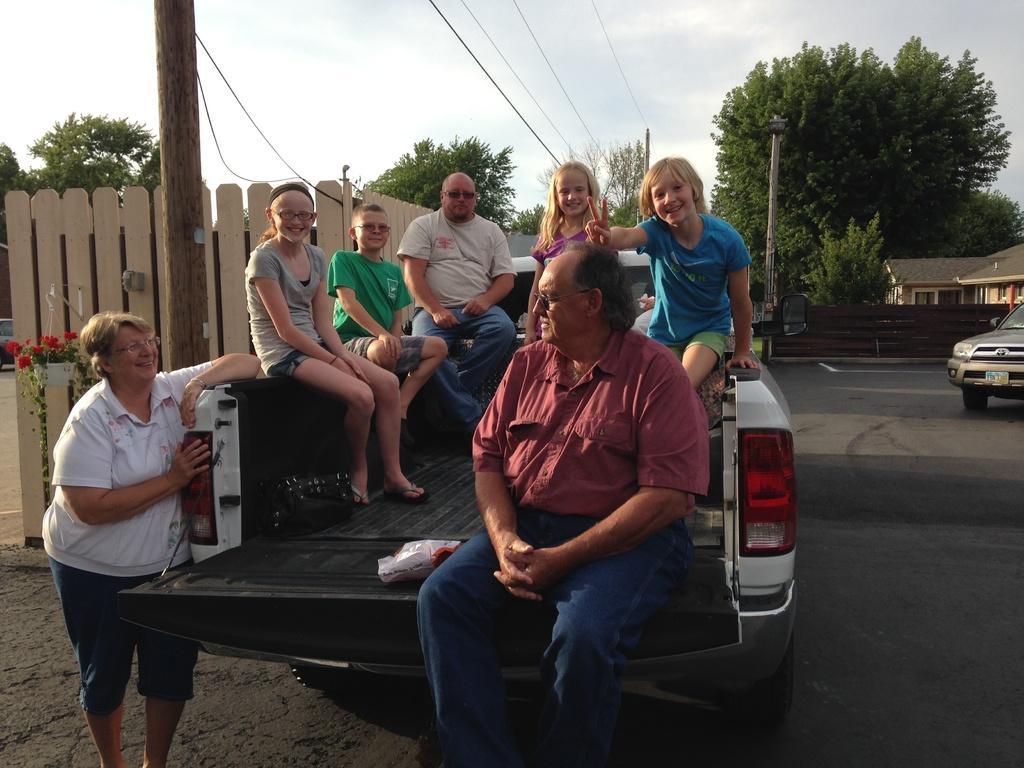In one or two sentences, can you explain what this image depicts? In this image we can see a group of people sitting in a vehicle which is placed on the road. We can also see a woman standing beside them, a plant with some flowers, a fence, a wooden pole, wires, some poles, a group of trees, some houses with roof and windows, a car on the road and the sky which looks cloudy. 